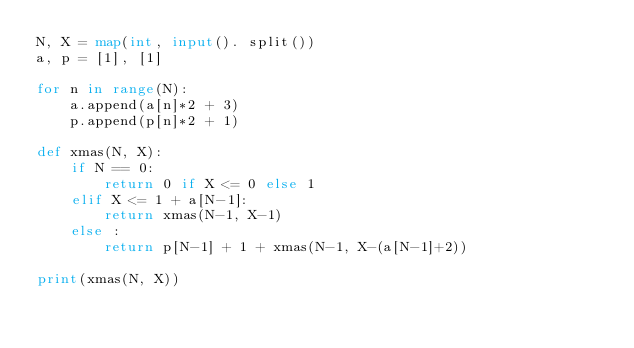Convert code to text. <code><loc_0><loc_0><loc_500><loc_500><_Python_>N, X = map(int, input(). split())
a, p = [1], [1]

for n in range(N):
    a.append(a[n]*2 + 3)
    p.append(p[n]*2 + 1)

def xmas(N, X):
    if N == 0:
        return 0 if X <= 0 else 1
    elif X <= 1 + a[N-1]:
        return xmas(N-1, X-1)
    else :
        return p[N-1] + 1 + xmas(N-1, X-(a[N-1]+2))

print(xmas(N, X))</code> 